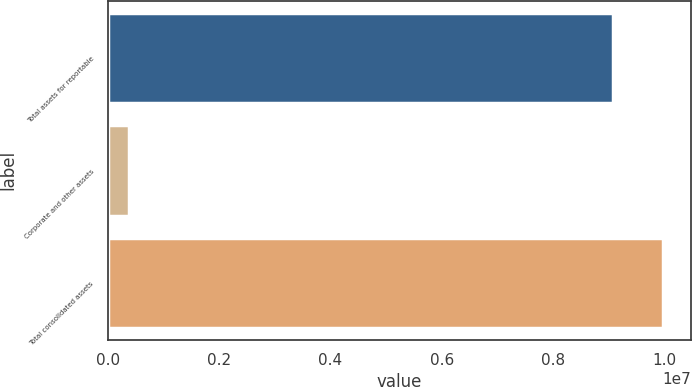<chart> <loc_0><loc_0><loc_500><loc_500><bar_chart><fcel>Total assets for reportable<fcel>Corporate and other assets<fcel>Total consolidated assets<nl><fcel>9.07413e+06<fcel>367739<fcel>9.98154e+06<nl></chart> 